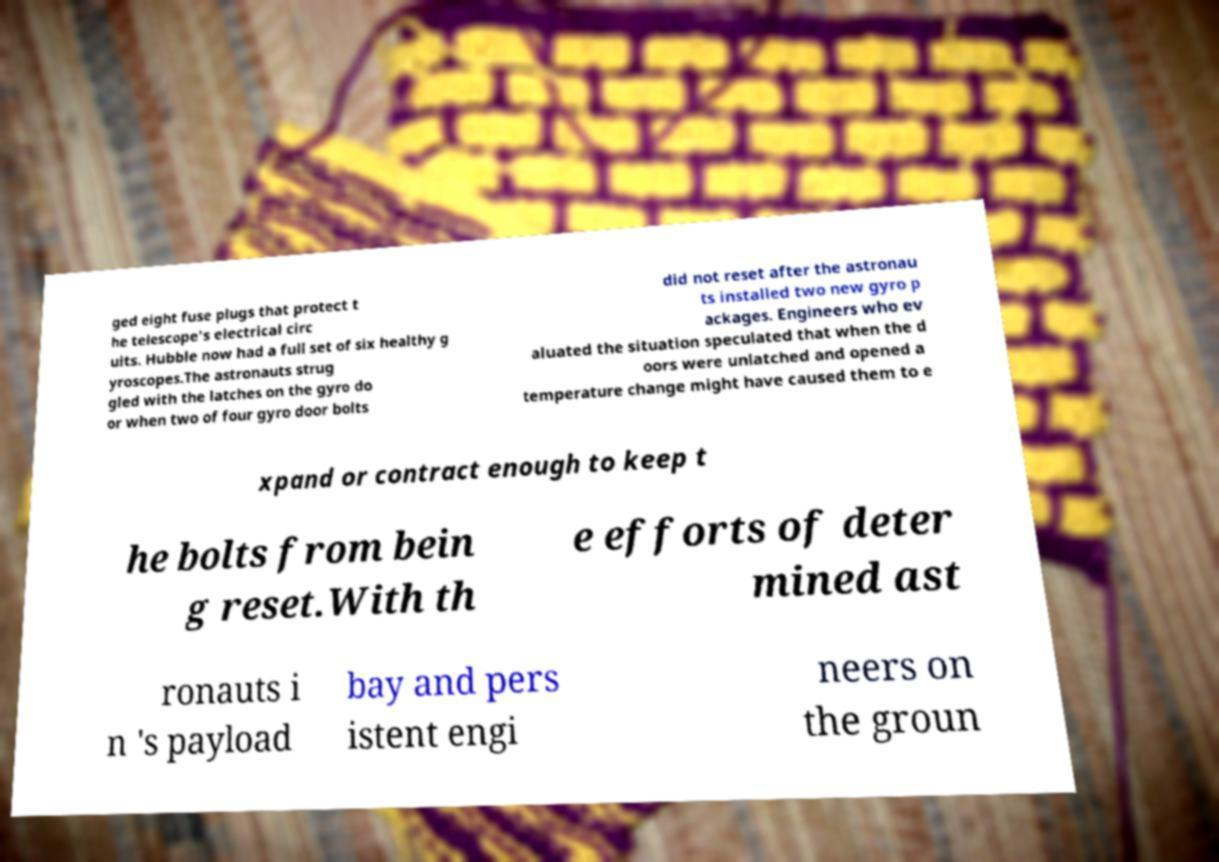Can you accurately transcribe the text from the provided image for me? ged eight fuse plugs that protect t he telescope's electrical circ uits. Hubble now had a full set of six healthy g yroscopes.The astronauts strug gled with the latches on the gyro do or when two of four gyro door bolts did not reset after the astronau ts installed two new gyro p ackages. Engineers who ev aluated the situation speculated that when the d oors were unlatched and opened a temperature change might have caused them to e xpand or contract enough to keep t he bolts from bein g reset.With th e efforts of deter mined ast ronauts i n 's payload bay and pers istent engi neers on the groun 